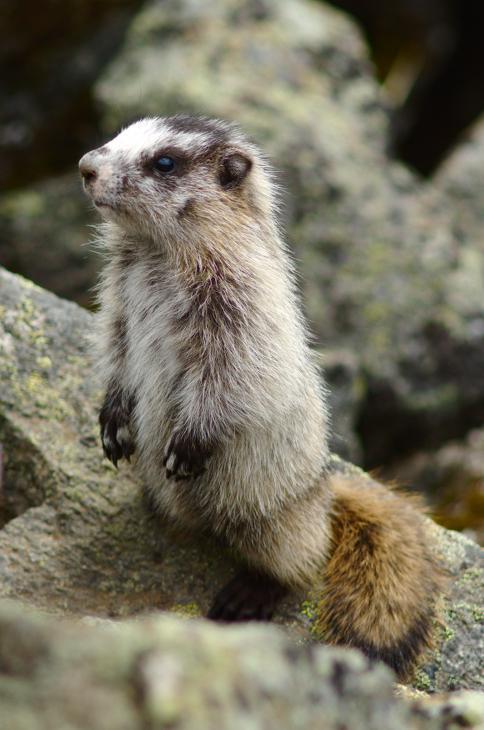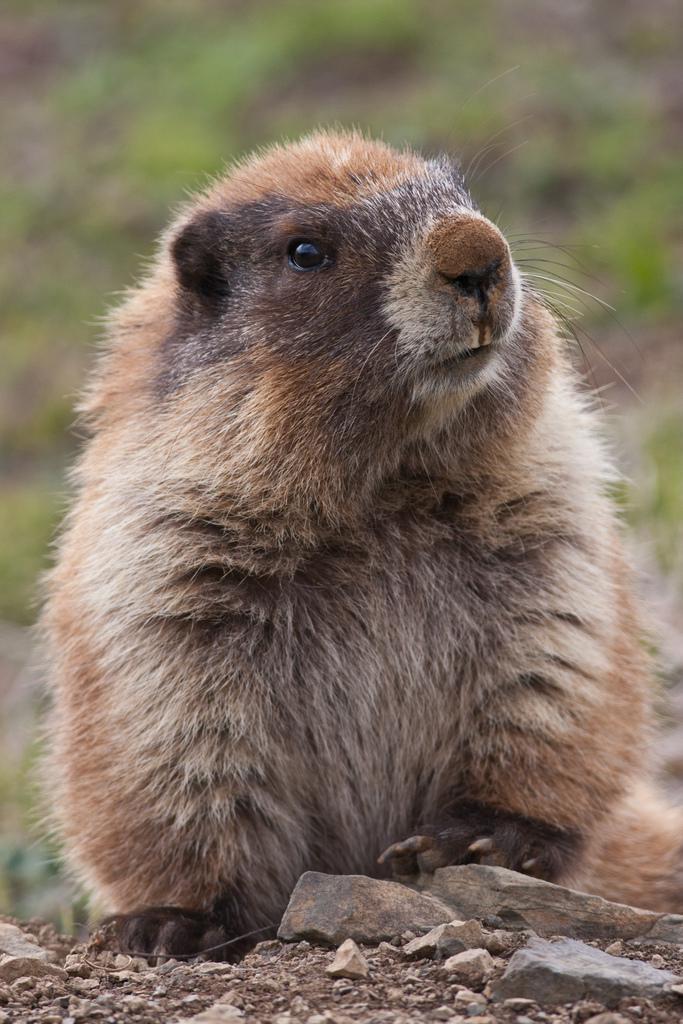The first image is the image on the left, the second image is the image on the right. Assess this claim about the two images: "In one image the prairie dog is eating food that it is holding in its paws.". Correct or not? Answer yes or no. No. 